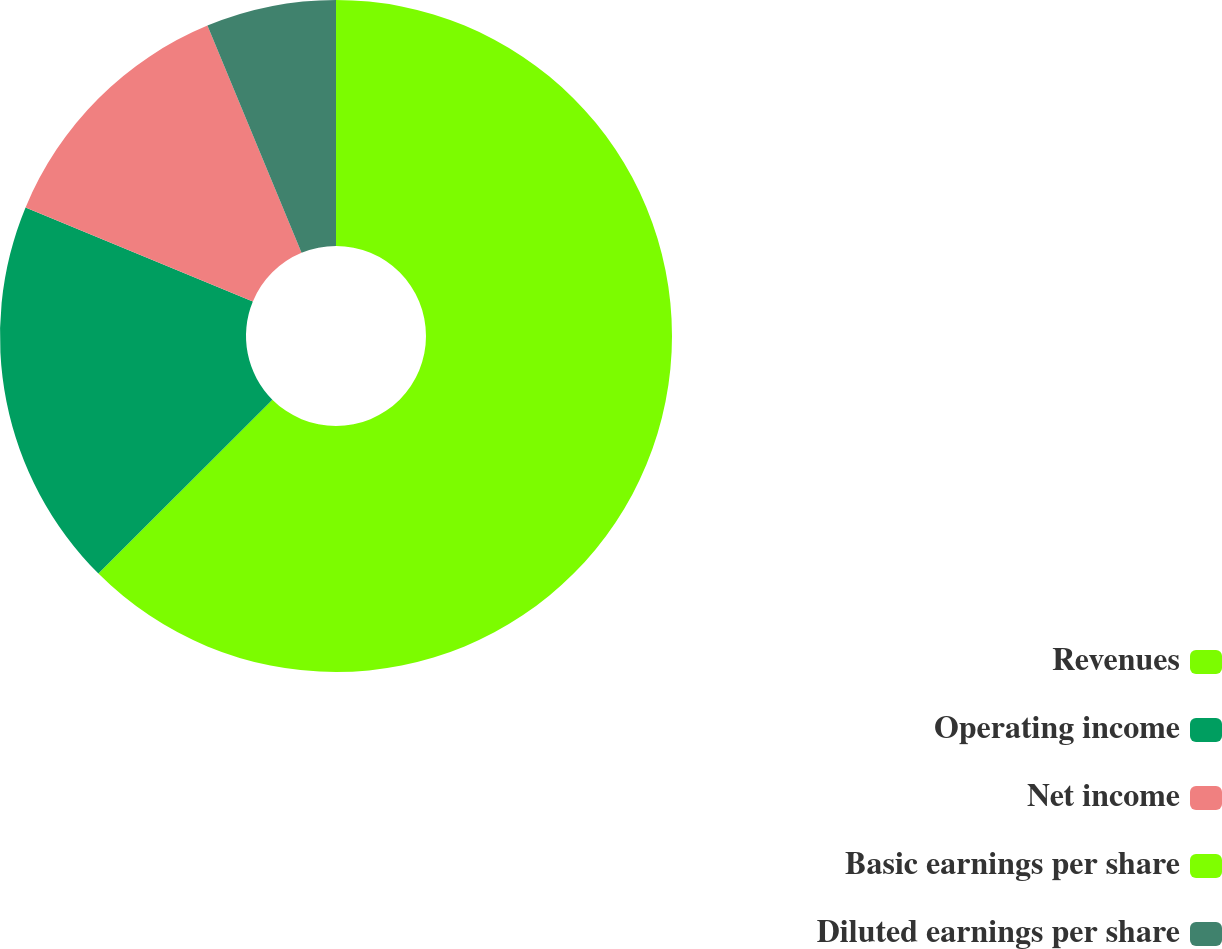Convert chart to OTSL. <chart><loc_0><loc_0><loc_500><loc_500><pie_chart><fcel>Revenues<fcel>Operating income<fcel>Net income<fcel>Basic earnings per share<fcel>Diluted earnings per share<nl><fcel>62.5%<fcel>18.75%<fcel>12.5%<fcel>0.0%<fcel>6.25%<nl></chart> 